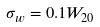<formula> <loc_0><loc_0><loc_500><loc_500>\sigma _ { w } = 0 . 1 W _ { 2 0 }</formula> 